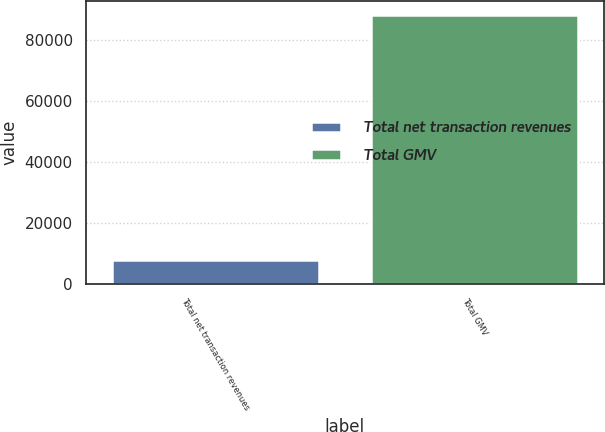Convert chart to OTSL. <chart><loc_0><loc_0><loc_500><loc_500><bar_chart><fcel>Total net transaction revenues<fcel>Total GMV<nl><fcel>7820<fcel>88403<nl></chart> 